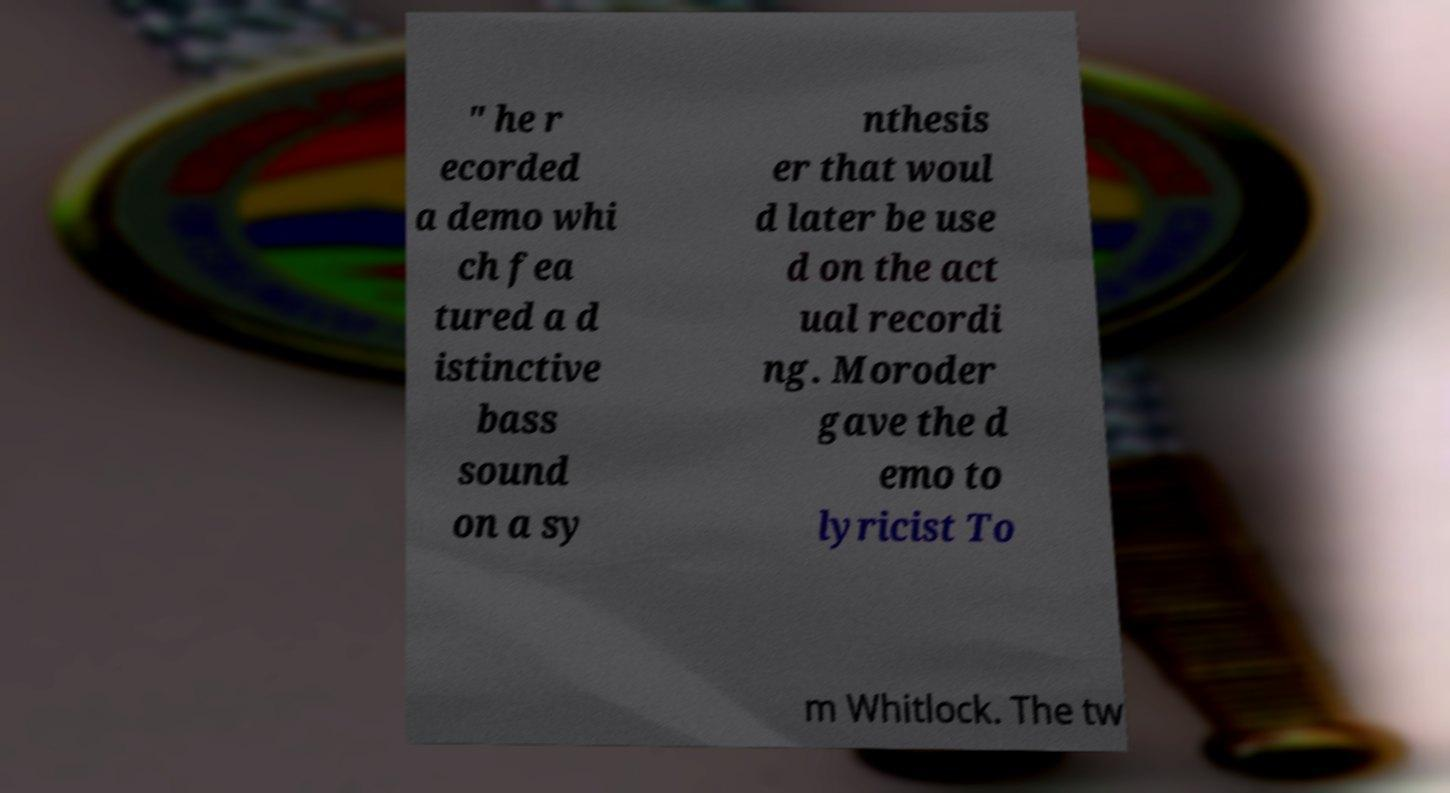Please identify and transcribe the text found in this image. " he r ecorded a demo whi ch fea tured a d istinctive bass sound on a sy nthesis er that woul d later be use d on the act ual recordi ng. Moroder gave the d emo to lyricist To m Whitlock. The tw 